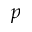<formula> <loc_0><loc_0><loc_500><loc_500>p</formula> 